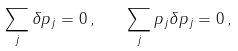Convert formula to latex. <formula><loc_0><loc_0><loc_500><loc_500>\sum _ { j } \delta p _ { j } = 0 \, , \quad \sum _ { j } p _ { j } \delta p _ { j } = 0 \, ,</formula> 